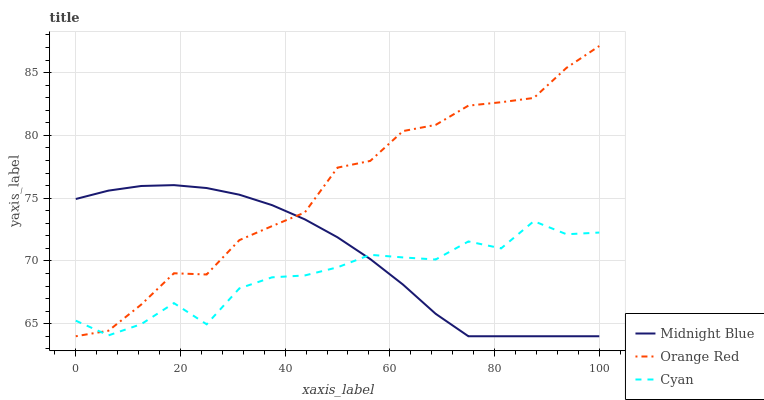Does Cyan have the minimum area under the curve?
Answer yes or no. Yes. Does Orange Red have the maximum area under the curve?
Answer yes or no. Yes. Does Midnight Blue have the minimum area under the curve?
Answer yes or no. No. Does Midnight Blue have the maximum area under the curve?
Answer yes or no. No. Is Midnight Blue the smoothest?
Answer yes or no. Yes. Is Cyan the roughest?
Answer yes or no. Yes. Is Orange Red the smoothest?
Answer yes or no. No. Is Orange Red the roughest?
Answer yes or no. No. Does Midnight Blue have the lowest value?
Answer yes or no. Yes. Does Orange Red have the highest value?
Answer yes or no. Yes. Does Midnight Blue have the highest value?
Answer yes or no. No. Does Orange Red intersect Midnight Blue?
Answer yes or no. Yes. Is Orange Red less than Midnight Blue?
Answer yes or no. No. Is Orange Red greater than Midnight Blue?
Answer yes or no. No. 